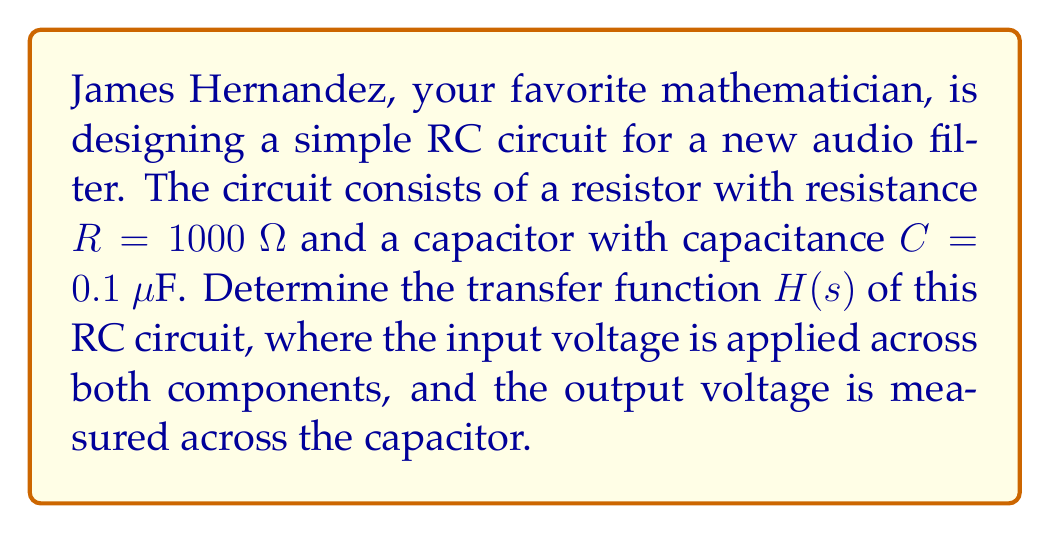Could you help me with this problem? Let's approach this step-by-step:

1) In an RC circuit, the transfer function H(s) is defined as the ratio of output voltage to input voltage in the s-domain:

   $$ H(s) = \frac{V_{out}(s)}{V_{in}(s)} $$

2) For an RC low-pass filter, where the output is taken across the capacitor:

   $$ H(s) = \frac{1/sC}{R + 1/sC} $$

3) This can be simplified to:

   $$ H(s) = \frac{1}{1 + sRC} $$

4) We're given R = 1000 Ω and C = 0.1 μF. Let's convert 0.1 μF to farads:

   $$ 0.1 \text{ μF} = 0.1 \times 10^{-6} \text{ F} = 10^{-7} \text{ F} $$

5) Now, let's substitute these values into our transfer function:

   $$ H(s) = \frac{1}{1 + s(1000)(10^{-7})} = \frac{1}{1 + 10^{-4}s} $$

6) We can also write this in a standard form with the time constant τ = RC:

   $$ H(s) = \frac{1}{1 + \tau s} $$

   where τ = RC = 1000 × 10^-7 = 10^-4 seconds or 0.1 ms.

This transfer function represents a first-order low-pass filter with a cutoff frequency of 1/τ = 10,000 rad/s or about 1592 Hz.
Answer: $$ H(s) = \frac{1}{1 + 10^{-4}s} $$ 